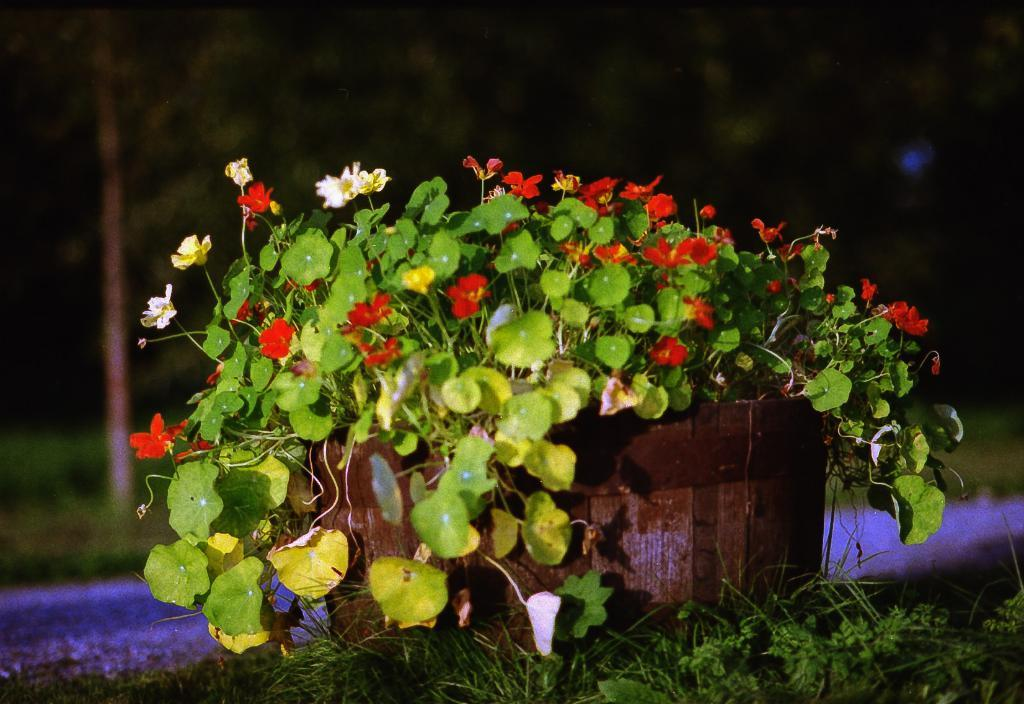What type of plant is present in the image? There are flowers in a potted plant in the image. What can be seen in the foreground of the image? The foreground of the image includes grass. What brand of toothpaste is being advertised in the image? There is no toothpaste or advertisement present in the image; it features a potted plant with flowers and grass in the foreground. 